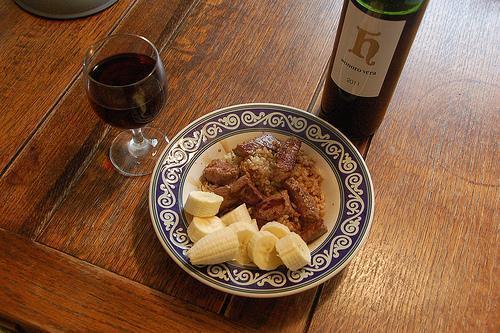How many plates are there?
Give a very brief answer. 1. How many wine glasses appear hear?
Give a very brief answer. 1. How many bottles of wine are pictured?
Give a very brief answer. 1. How many people appear in this photo?
Give a very brief answer. 0. 